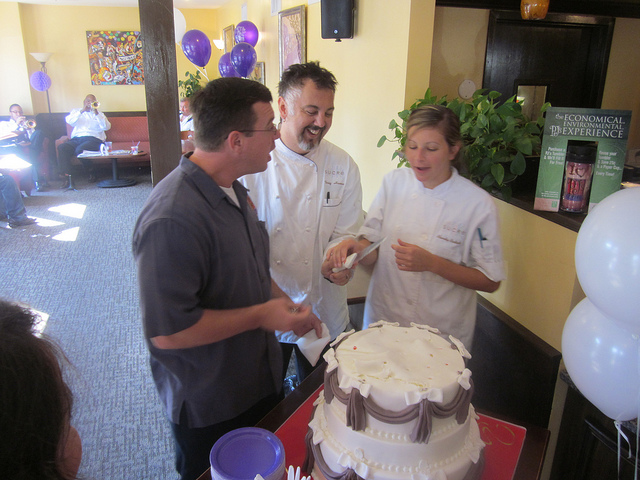<image>Does these mean belong to the same group? It's ambiguous whether these items belong to the same group. The responses are mixed. Does these mean belong to the same group? I'm not sure if these means belong to the same group. It can be both yes and no. 